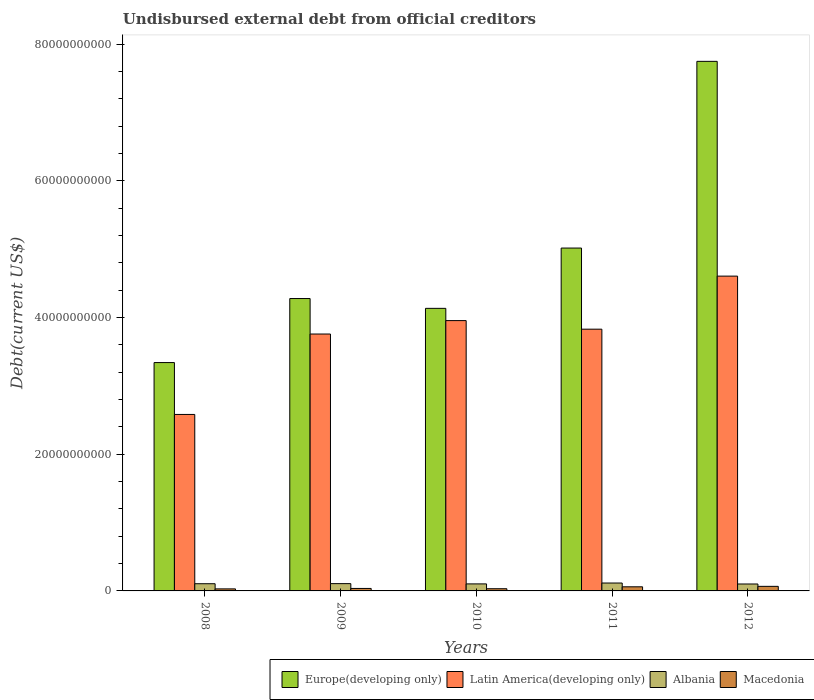How many groups of bars are there?
Make the answer very short. 5. Are the number of bars per tick equal to the number of legend labels?
Your response must be concise. Yes. Are the number of bars on each tick of the X-axis equal?
Ensure brevity in your answer.  Yes. How many bars are there on the 3rd tick from the right?
Give a very brief answer. 4. In how many cases, is the number of bars for a given year not equal to the number of legend labels?
Provide a short and direct response. 0. What is the total debt in Latin America(developing only) in 2008?
Provide a succinct answer. 2.58e+1. Across all years, what is the maximum total debt in Latin America(developing only)?
Ensure brevity in your answer.  4.61e+1. Across all years, what is the minimum total debt in Macedonia?
Offer a very short reply. 2.98e+08. In which year was the total debt in Europe(developing only) minimum?
Your answer should be compact. 2008. What is the total total debt in Europe(developing only) in the graph?
Provide a short and direct response. 2.45e+11. What is the difference between the total debt in Albania in 2008 and that in 2012?
Make the answer very short. 3.99e+07. What is the difference between the total debt in Macedonia in 2008 and the total debt in Europe(developing only) in 2012?
Provide a succinct answer. -7.72e+1. What is the average total debt in Latin America(developing only) per year?
Make the answer very short. 3.75e+1. In the year 2010, what is the difference between the total debt in Europe(developing only) and total debt in Latin America(developing only)?
Offer a very short reply. 1.79e+09. In how many years, is the total debt in Latin America(developing only) greater than 24000000000 US$?
Keep it short and to the point. 5. What is the ratio of the total debt in Latin America(developing only) in 2008 to that in 2009?
Ensure brevity in your answer.  0.69. Is the total debt in Latin America(developing only) in 2010 less than that in 2011?
Keep it short and to the point. No. What is the difference between the highest and the second highest total debt in Albania?
Offer a terse response. 8.86e+07. What is the difference between the highest and the lowest total debt in Macedonia?
Your answer should be very brief. 3.71e+08. In how many years, is the total debt in Macedonia greater than the average total debt in Macedonia taken over all years?
Provide a succinct answer. 2. Is the sum of the total debt in Macedonia in 2009 and 2012 greater than the maximum total debt in Albania across all years?
Ensure brevity in your answer.  No. What does the 4th bar from the left in 2011 represents?
Ensure brevity in your answer.  Macedonia. What does the 1st bar from the right in 2011 represents?
Provide a short and direct response. Macedonia. Is it the case that in every year, the sum of the total debt in Macedonia and total debt in Latin America(developing only) is greater than the total debt in Albania?
Make the answer very short. Yes. Are all the bars in the graph horizontal?
Ensure brevity in your answer.  No. How many years are there in the graph?
Offer a terse response. 5. Does the graph contain grids?
Keep it short and to the point. No. How many legend labels are there?
Provide a succinct answer. 4. How are the legend labels stacked?
Give a very brief answer. Horizontal. What is the title of the graph?
Provide a succinct answer. Undisbursed external debt from official creditors. Does "Nepal" appear as one of the legend labels in the graph?
Make the answer very short. No. What is the label or title of the Y-axis?
Give a very brief answer. Debt(current US$). What is the Debt(current US$) of Europe(developing only) in 2008?
Keep it short and to the point. 3.34e+1. What is the Debt(current US$) in Latin America(developing only) in 2008?
Ensure brevity in your answer.  2.58e+1. What is the Debt(current US$) in Albania in 2008?
Offer a terse response. 1.05e+09. What is the Debt(current US$) in Macedonia in 2008?
Make the answer very short. 2.98e+08. What is the Debt(current US$) of Europe(developing only) in 2009?
Your answer should be very brief. 4.28e+1. What is the Debt(current US$) of Latin America(developing only) in 2009?
Keep it short and to the point. 3.76e+1. What is the Debt(current US$) of Albania in 2009?
Your answer should be compact. 1.07e+09. What is the Debt(current US$) in Macedonia in 2009?
Keep it short and to the point. 3.63e+08. What is the Debt(current US$) in Europe(developing only) in 2010?
Give a very brief answer. 4.13e+1. What is the Debt(current US$) of Latin America(developing only) in 2010?
Provide a succinct answer. 3.95e+1. What is the Debt(current US$) of Albania in 2010?
Make the answer very short. 1.03e+09. What is the Debt(current US$) in Macedonia in 2010?
Your answer should be compact. 3.21e+08. What is the Debt(current US$) in Europe(developing only) in 2011?
Your response must be concise. 5.02e+1. What is the Debt(current US$) in Latin America(developing only) in 2011?
Provide a short and direct response. 3.83e+1. What is the Debt(current US$) of Albania in 2011?
Your answer should be very brief. 1.16e+09. What is the Debt(current US$) in Macedonia in 2011?
Offer a terse response. 6.02e+08. What is the Debt(current US$) of Europe(developing only) in 2012?
Offer a terse response. 7.75e+1. What is the Debt(current US$) of Latin America(developing only) in 2012?
Offer a very short reply. 4.61e+1. What is the Debt(current US$) in Albania in 2012?
Make the answer very short. 1.01e+09. What is the Debt(current US$) in Macedonia in 2012?
Ensure brevity in your answer.  6.68e+08. Across all years, what is the maximum Debt(current US$) in Europe(developing only)?
Make the answer very short. 7.75e+1. Across all years, what is the maximum Debt(current US$) of Latin America(developing only)?
Your response must be concise. 4.61e+1. Across all years, what is the maximum Debt(current US$) of Albania?
Make the answer very short. 1.16e+09. Across all years, what is the maximum Debt(current US$) in Macedonia?
Keep it short and to the point. 6.68e+08. Across all years, what is the minimum Debt(current US$) of Europe(developing only)?
Your answer should be compact. 3.34e+1. Across all years, what is the minimum Debt(current US$) in Latin America(developing only)?
Provide a short and direct response. 2.58e+1. Across all years, what is the minimum Debt(current US$) of Albania?
Keep it short and to the point. 1.01e+09. Across all years, what is the minimum Debt(current US$) in Macedonia?
Provide a succinct answer. 2.98e+08. What is the total Debt(current US$) in Europe(developing only) in the graph?
Ensure brevity in your answer.  2.45e+11. What is the total Debt(current US$) of Latin America(developing only) in the graph?
Your answer should be very brief. 1.87e+11. What is the total Debt(current US$) of Albania in the graph?
Give a very brief answer. 5.32e+09. What is the total Debt(current US$) of Macedonia in the graph?
Offer a terse response. 2.25e+09. What is the difference between the Debt(current US$) in Europe(developing only) in 2008 and that in 2009?
Your answer should be compact. -9.37e+09. What is the difference between the Debt(current US$) of Latin America(developing only) in 2008 and that in 2009?
Your response must be concise. -1.18e+1. What is the difference between the Debt(current US$) of Albania in 2008 and that in 2009?
Make the answer very short. -1.40e+07. What is the difference between the Debt(current US$) in Macedonia in 2008 and that in 2009?
Offer a very short reply. -6.54e+07. What is the difference between the Debt(current US$) in Europe(developing only) in 2008 and that in 2010?
Provide a succinct answer. -7.93e+09. What is the difference between the Debt(current US$) in Latin America(developing only) in 2008 and that in 2010?
Offer a very short reply. -1.37e+1. What is the difference between the Debt(current US$) in Albania in 2008 and that in 2010?
Give a very brief answer. 2.57e+07. What is the difference between the Debt(current US$) in Macedonia in 2008 and that in 2010?
Your answer should be compact. -2.33e+07. What is the difference between the Debt(current US$) of Europe(developing only) in 2008 and that in 2011?
Keep it short and to the point. -1.68e+1. What is the difference between the Debt(current US$) of Latin America(developing only) in 2008 and that in 2011?
Ensure brevity in your answer.  -1.25e+1. What is the difference between the Debt(current US$) in Albania in 2008 and that in 2011?
Provide a short and direct response. -1.03e+08. What is the difference between the Debt(current US$) in Macedonia in 2008 and that in 2011?
Give a very brief answer. -3.05e+08. What is the difference between the Debt(current US$) of Europe(developing only) in 2008 and that in 2012?
Your answer should be very brief. -4.41e+1. What is the difference between the Debt(current US$) of Latin America(developing only) in 2008 and that in 2012?
Give a very brief answer. -2.02e+1. What is the difference between the Debt(current US$) of Albania in 2008 and that in 2012?
Your response must be concise. 3.99e+07. What is the difference between the Debt(current US$) in Macedonia in 2008 and that in 2012?
Provide a short and direct response. -3.71e+08. What is the difference between the Debt(current US$) of Europe(developing only) in 2009 and that in 2010?
Ensure brevity in your answer.  1.44e+09. What is the difference between the Debt(current US$) of Latin America(developing only) in 2009 and that in 2010?
Your response must be concise. -1.96e+09. What is the difference between the Debt(current US$) in Albania in 2009 and that in 2010?
Offer a terse response. 3.97e+07. What is the difference between the Debt(current US$) in Macedonia in 2009 and that in 2010?
Ensure brevity in your answer.  4.20e+07. What is the difference between the Debt(current US$) in Europe(developing only) in 2009 and that in 2011?
Provide a succinct answer. -7.39e+09. What is the difference between the Debt(current US$) in Latin America(developing only) in 2009 and that in 2011?
Provide a succinct answer. -7.08e+08. What is the difference between the Debt(current US$) in Albania in 2009 and that in 2011?
Offer a terse response. -8.86e+07. What is the difference between the Debt(current US$) in Macedonia in 2009 and that in 2011?
Offer a very short reply. -2.39e+08. What is the difference between the Debt(current US$) of Europe(developing only) in 2009 and that in 2012?
Provide a succinct answer. -3.47e+1. What is the difference between the Debt(current US$) of Latin America(developing only) in 2009 and that in 2012?
Provide a succinct answer. -8.47e+09. What is the difference between the Debt(current US$) of Albania in 2009 and that in 2012?
Make the answer very short. 5.39e+07. What is the difference between the Debt(current US$) of Macedonia in 2009 and that in 2012?
Keep it short and to the point. -3.05e+08. What is the difference between the Debt(current US$) in Europe(developing only) in 2010 and that in 2011?
Make the answer very short. -8.82e+09. What is the difference between the Debt(current US$) in Latin America(developing only) in 2010 and that in 2011?
Offer a very short reply. 1.25e+09. What is the difference between the Debt(current US$) of Albania in 2010 and that in 2011?
Make the answer very short. -1.28e+08. What is the difference between the Debt(current US$) in Macedonia in 2010 and that in 2011?
Your answer should be very brief. -2.81e+08. What is the difference between the Debt(current US$) of Europe(developing only) in 2010 and that in 2012?
Offer a terse response. -3.61e+1. What is the difference between the Debt(current US$) of Latin America(developing only) in 2010 and that in 2012?
Your answer should be compact. -6.51e+09. What is the difference between the Debt(current US$) in Albania in 2010 and that in 2012?
Offer a very short reply. 1.42e+07. What is the difference between the Debt(current US$) of Macedonia in 2010 and that in 2012?
Provide a short and direct response. -3.47e+08. What is the difference between the Debt(current US$) in Europe(developing only) in 2011 and that in 2012?
Make the answer very short. -2.73e+1. What is the difference between the Debt(current US$) in Latin America(developing only) in 2011 and that in 2012?
Your response must be concise. -7.76e+09. What is the difference between the Debt(current US$) in Albania in 2011 and that in 2012?
Give a very brief answer. 1.43e+08. What is the difference between the Debt(current US$) in Macedonia in 2011 and that in 2012?
Your answer should be very brief. -6.60e+07. What is the difference between the Debt(current US$) in Europe(developing only) in 2008 and the Debt(current US$) in Latin America(developing only) in 2009?
Your answer should be very brief. -4.18e+09. What is the difference between the Debt(current US$) of Europe(developing only) in 2008 and the Debt(current US$) of Albania in 2009?
Make the answer very short. 3.23e+1. What is the difference between the Debt(current US$) in Europe(developing only) in 2008 and the Debt(current US$) in Macedonia in 2009?
Ensure brevity in your answer.  3.30e+1. What is the difference between the Debt(current US$) in Latin America(developing only) in 2008 and the Debt(current US$) in Albania in 2009?
Ensure brevity in your answer.  2.48e+1. What is the difference between the Debt(current US$) of Latin America(developing only) in 2008 and the Debt(current US$) of Macedonia in 2009?
Your response must be concise. 2.55e+1. What is the difference between the Debt(current US$) of Albania in 2008 and the Debt(current US$) of Macedonia in 2009?
Make the answer very short. 6.90e+08. What is the difference between the Debt(current US$) of Europe(developing only) in 2008 and the Debt(current US$) of Latin America(developing only) in 2010?
Ensure brevity in your answer.  -6.14e+09. What is the difference between the Debt(current US$) in Europe(developing only) in 2008 and the Debt(current US$) in Albania in 2010?
Give a very brief answer. 3.24e+1. What is the difference between the Debt(current US$) in Europe(developing only) in 2008 and the Debt(current US$) in Macedonia in 2010?
Provide a succinct answer. 3.31e+1. What is the difference between the Debt(current US$) in Latin America(developing only) in 2008 and the Debt(current US$) in Albania in 2010?
Ensure brevity in your answer.  2.48e+1. What is the difference between the Debt(current US$) of Latin America(developing only) in 2008 and the Debt(current US$) of Macedonia in 2010?
Keep it short and to the point. 2.55e+1. What is the difference between the Debt(current US$) in Albania in 2008 and the Debt(current US$) in Macedonia in 2010?
Provide a short and direct response. 7.32e+08. What is the difference between the Debt(current US$) of Europe(developing only) in 2008 and the Debt(current US$) of Latin America(developing only) in 2011?
Keep it short and to the point. -4.89e+09. What is the difference between the Debt(current US$) in Europe(developing only) in 2008 and the Debt(current US$) in Albania in 2011?
Provide a short and direct response. 3.23e+1. What is the difference between the Debt(current US$) of Europe(developing only) in 2008 and the Debt(current US$) of Macedonia in 2011?
Your answer should be very brief. 3.28e+1. What is the difference between the Debt(current US$) in Latin America(developing only) in 2008 and the Debt(current US$) in Albania in 2011?
Make the answer very short. 2.47e+1. What is the difference between the Debt(current US$) of Latin America(developing only) in 2008 and the Debt(current US$) of Macedonia in 2011?
Provide a short and direct response. 2.52e+1. What is the difference between the Debt(current US$) in Albania in 2008 and the Debt(current US$) in Macedonia in 2011?
Your response must be concise. 4.51e+08. What is the difference between the Debt(current US$) of Europe(developing only) in 2008 and the Debt(current US$) of Latin America(developing only) in 2012?
Your response must be concise. -1.26e+1. What is the difference between the Debt(current US$) of Europe(developing only) in 2008 and the Debt(current US$) of Albania in 2012?
Offer a terse response. 3.24e+1. What is the difference between the Debt(current US$) of Europe(developing only) in 2008 and the Debt(current US$) of Macedonia in 2012?
Make the answer very short. 3.27e+1. What is the difference between the Debt(current US$) in Latin America(developing only) in 2008 and the Debt(current US$) in Albania in 2012?
Ensure brevity in your answer.  2.48e+1. What is the difference between the Debt(current US$) in Latin America(developing only) in 2008 and the Debt(current US$) in Macedonia in 2012?
Offer a very short reply. 2.52e+1. What is the difference between the Debt(current US$) in Albania in 2008 and the Debt(current US$) in Macedonia in 2012?
Your answer should be very brief. 3.85e+08. What is the difference between the Debt(current US$) of Europe(developing only) in 2009 and the Debt(current US$) of Latin America(developing only) in 2010?
Your answer should be compact. 3.23e+09. What is the difference between the Debt(current US$) of Europe(developing only) in 2009 and the Debt(current US$) of Albania in 2010?
Keep it short and to the point. 4.18e+1. What is the difference between the Debt(current US$) in Europe(developing only) in 2009 and the Debt(current US$) in Macedonia in 2010?
Provide a succinct answer. 4.25e+1. What is the difference between the Debt(current US$) in Latin America(developing only) in 2009 and the Debt(current US$) in Albania in 2010?
Your response must be concise. 3.66e+1. What is the difference between the Debt(current US$) of Latin America(developing only) in 2009 and the Debt(current US$) of Macedonia in 2010?
Your response must be concise. 3.73e+1. What is the difference between the Debt(current US$) in Albania in 2009 and the Debt(current US$) in Macedonia in 2010?
Provide a succinct answer. 7.46e+08. What is the difference between the Debt(current US$) of Europe(developing only) in 2009 and the Debt(current US$) of Latin America(developing only) in 2011?
Your response must be concise. 4.48e+09. What is the difference between the Debt(current US$) in Europe(developing only) in 2009 and the Debt(current US$) in Albania in 2011?
Offer a terse response. 4.16e+1. What is the difference between the Debt(current US$) in Europe(developing only) in 2009 and the Debt(current US$) in Macedonia in 2011?
Offer a terse response. 4.22e+1. What is the difference between the Debt(current US$) in Latin America(developing only) in 2009 and the Debt(current US$) in Albania in 2011?
Offer a terse response. 3.64e+1. What is the difference between the Debt(current US$) of Latin America(developing only) in 2009 and the Debt(current US$) of Macedonia in 2011?
Keep it short and to the point. 3.70e+1. What is the difference between the Debt(current US$) in Albania in 2009 and the Debt(current US$) in Macedonia in 2011?
Provide a short and direct response. 4.65e+08. What is the difference between the Debt(current US$) in Europe(developing only) in 2009 and the Debt(current US$) in Latin America(developing only) in 2012?
Make the answer very short. -3.28e+09. What is the difference between the Debt(current US$) in Europe(developing only) in 2009 and the Debt(current US$) in Albania in 2012?
Your answer should be compact. 4.18e+1. What is the difference between the Debt(current US$) of Europe(developing only) in 2009 and the Debt(current US$) of Macedonia in 2012?
Your answer should be compact. 4.21e+1. What is the difference between the Debt(current US$) of Latin America(developing only) in 2009 and the Debt(current US$) of Albania in 2012?
Provide a short and direct response. 3.66e+1. What is the difference between the Debt(current US$) of Latin America(developing only) in 2009 and the Debt(current US$) of Macedonia in 2012?
Offer a terse response. 3.69e+1. What is the difference between the Debt(current US$) in Albania in 2009 and the Debt(current US$) in Macedonia in 2012?
Keep it short and to the point. 3.99e+08. What is the difference between the Debt(current US$) of Europe(developing only) in 2010 and the Debt(current US$) of Latin America(developing only) in 2011?
Make the answer very short. 3.05e+09. What is the difference between the Debt(current US$) of Europe(developing only) in 2010 and the Debt(current US$) of Albania in 2011?
Your response must be concise. 4.02e+1. What is the difference between the Debt(current US$) in Europe(developing only) in 2010 and the Debt(current US$) in Macedonia in 2011?
Your response must be concise. 4.07e+1. What is the difference between the Debt(current US$) in Latin America(developing only) in 2010 and the Debt(current US$) in Albania in 2011?
Give a very brief answer. 3.84e+1. What is the difference between the Debt(current US$) in Latin America(developing only) in 2010 and the Debt(current US$) in Macedonia in 2011?
Provide a short and direct response. 3.89e+1. What is the difference between the Debt(current US$) of Albania in 2010 and the Debt(current US$) of Macedonia in 2011?
Your answer should be compact. 4.25e+08. What is the difference between the Debt(current US$) of Europe(developing only) in 2010 and the Debt(current US$) of Latin America(developing only) in 2012?
Make the answer very short. -4.72e+09. What is the difference between the Debt(current US$) of Europe(developing only) in 2010 and the Debt(current US$) of Albania in 2012?
Offer a terse response. 4.03e+1. What is the difference between the Debt(current US$) of Europe(developing only) in 2010 and the Debt(current US$) of Macedonia in 2012?
Provide a short and direct response. 4.07e+1. What is the difference between the Debt(current US$) in Latin America(developing only) in 2010 and the Debt(current US$) in Albania in 2012?
Your answer should be very brief. 3.85e+1. What is the difference between the Debt(current US$) of Latin America(developing only) in 2010 and the Debt(current US$) of Macedonia in 2012?
Provide a succinct answer. 3.89e+1. What is the difference between the Debt(current US$) of Albania in 2010 and the Debt(current US$) of Macedonia in 2012?
Provide a succinct answer. 3.59e+08. What is the difference between the Debt(current US$) in Europe(developing only) in 2011 and the Debt(current US$) in Latin America(developing only) in 2012?
Provide a short and direct response. 4.11e+09. What is the difference between the Debt(current US$) of Europe(developing only) in 2011 and the Debt(current US$) of Albania in 2012?
Your answer should be compact. 4.92e+1. What is the difference between the Debt(current US$) of Europe(developing only) in 2011 and the Debt(current US$) of Macedonia in 2012?
Your answer should be very brief. 4.95e+1. What is the difference between the Debt(current US$) of Latin America(developing only) in 2011 and the Debt(current US$) of Albania in 2012?
Your answer should be compact. 3.73e+1. What is the difference between the Debt(current US$) of Latin America(developing only) in 2011 and the Debt(current US$) of Macedonia in 2012?
Give a very brief answer. 3.76e+1. What is the difference between the Debt(current US$) of Albania in 2011 and the Debt(current US$) of Macedonia in 2012?
Give a very brief answer. 4.87e+08. What is the average Debt(current US$) of Europe(developing only) per year?
Keep it short and to the point. 4.90e+1. What is the average Debt(current US$) in Latin America(developing only) per year?
Make the answer very short. 3.75e+1. What is the average Debt(current US$) of Albania per year?
Offer a terse response. 1.06e+09. What is the average Debt(current US$) in Macedonia per year?
Your answer should be compact. 4.50e+08. In the year 2008, what is the difference between the Debt(current US$) of Europe(developing only) and Debt(current US$) of Latin America(developing only)?
Provide a succinct answer. 7.59e+09. In the year 2008, what is the difference between the Debt(current US$) in Europe(developing only) and Debt(current US$) in Albania?
Your answer should be compact. 3.24e+1. In the year 2008, what is the difference between the Debt(current US$) in Europe(developing only) and Debt(current US$) in Macedonia?
Give a very brief answer. 3.31e+1. In the year 2008, what is the difference between the Debt(current US$) of Latin America(developing only) and Debt(current US$) of Albania?
Give a very brief answer. 2.48e+1. In the year 2008, what is the difference between the Debt(current US$) of Latin America(developing only) and Debt(current US$) of Macedonia?
Your answer should be compact. 2.55e+1. In the year 2008, what is the difference between the Debt(current US$) of Albania and Debt(current US$) of Macedonia?
Your answer should be compact. 7.55e+08. In the year 2009, what is the difference between the Debt(current US$) in Europe(developing only) and Debt(current US$) in Latin America(developing only)?
Your answer should be very brief. 5.19e+09. In the year 2009, what is the difference between the Debt(current US$) in Europe(developing only) and Debt(current US$) in Albania?
Provide a short and direct response. 4.17e+1. In the year 2009, what is the difference between the Debt(current US$) of Europe(developing only) and Debt(current US$) of Macedonia?
Make the answer very short. 4.24e+1. In the year 2009, what is the difference between the Debt(current US$) of Latin America(developing only) and Debt(current US$) of Albania?
Make the answer very short. 3.65e+1. In the year 2009, what is the difference between the Debt(current US$) of Latin America(developing only) and Debt(current US$) of Macedonia?
Give a very brief answer. 3.72e+1. In the year 2009, what is the difference between the Debt(current US$) in Albania and Debt(current US$) in Macedonia?
Provide a succinct answer. 7.04e+08. In the year 2010, what is the difference between the Debt(current US$) of Europe(developing only) and Debt(current US$) of Latin America(developing only)?
Your answer should be very brief. 1.79e+09. In the year 2010, what is the difference between the Debt(current US$) in Europe(developing only) and Debt(current US$) in Albania?
Your answer should be very brief. 4.03e+1. In the year 2010, what is the difference between the Debt(current US$) of Europe(developing only) and Debt(current US$) of Macedonia?
Offer a terse response. 4.10e+1. In the year 2010, what is the difference between the Debt(current US$) in Latin America(developing only) and Debt(current US$) in Albania?
Your answer should be compact. 3.85e+1. In the year 2010, what is the difference between the Debt(current US$) of Latin America(developing only) and Debt(current US$) of Macedonia?
Offer a very short reply. 3.92e+1. In the year 2010, what is the difference between the Debt(current US$) of Albania and Debt(current US$) of Macedonia?
Ensure brevity in your answer.  7.06e+08. In the year 2011, what is the difference between the Debt(current US$) of Europe(developing only) and Debt(current US$) of Latin America(developing only)?
Provide a succinct answer. 1.19e+1. In the year 2011, what is the difference between the Debt(current US$) in Europe(developing only) and Debt(current US$) in Albania?
Provide a succinct answer. 4.90e+1. In the year 2011, what is the difference between the Debt(current US$) of Europe(developing only) and Debt(current US$) of Macedonia?
Ensure brevity in your answer.  4.96e+1. In the year 2011, what is the difference between the Debt(current US$) of Latin America(developing only) and Debt(current US$) of Albania?
Your response must be concise. 3.71e+1. In the year 2011, what is the difference between the Debt(current US$) in Latin America(developing only) and Debt(current US$) in Macedonia?
Provide a short and direct response. 3.77e+1. In the year 2011, what is the difference between the Debt(current US$) in Albania and Debt(current US$) in Macedonia?
Your answer should be compact. 5.53e+08. In the year 2012, what is the difference between the Debt(current US$) in Europe(developing only) and Debt(current US$) in Latin America(developing only)?
Make the answer very short. 3.14e+1. In the year 2012, what is the difference between the Debt(current US$) of Europe(developing only) and Debt(current US$) of Albania?
Your answer should be very brief. 7.65e+1. In the year 2012, what is the difference between the Debt(current US$) in Europe(developing only) and Debt(current US$) in Macedonia?
Make the answer very short. 7.68e+1. In the year 2012, what is the difference between the Debt(current US$) in Latin America(developing only) and Debt(current US$) in Albania?
Your answer should be very brief. 4.50e+1. In the year 2012, what is the difference between the Debt(current US$) of Latin America(developing only) and Debt(current US$) of Macedonia?
Your response must be concise. 4.54e+1. In the year 2012, what is the difference between the Debt(current US$) of Albania and Debt(current US$) of Macedonia?
Make the answer very short. 3.45e+08. What is the ratio of the Debt(current US$) in Europe(developing only) in 2008 to that in 2009?
Your answer should be very brief. 0.78. What is the ratio of the Debt(current US$) of Latin America(developing only) in 2008 to that in 2009?
Give a very brief answer. 0.69. What is the ratio of the Debt(current US$) of Albania in 2008 to that in 2009?
Your answer should be compact. 0.99. What is the ratio of the Debt(current US$) in Macedonia in 2008 to that in 2009?
Your answer should be very brief. 0.82. What is the ratio of the Debt(current US$) of Europe(developing only) in 2008 to that in 2010?
Your answer should be very brief. 0.81. What is the ratio of the Debt(current US$) of Latin America(developing only) in 2008 to that in 2010?
Keep it short and to the point. 0.65. What is the ratio of the Debt(current US$) in Macedonia in 2008 to that in 2010?
Offer a terse response. 0.93. What is the ratio of the Debt(current US$) of Europe(developing only) in 2008 to that in 2011?
Ensure brevity in your answer.  0.67. What is the ratio of the Debt(current US$) in Latin America(developing only) in 2008 to that in 2011?
Give a very brief answer. 0.67. What is the ratio of the Debt(current US$) in Albania in 2008 to that in 2011?
Ensure brevity in your answer.  0.91. What is the ratio of the Debt(current US$) in Macedonia in 2008 to that in 2011?
Provide a short and direct response. 0.49. What is the ratio of the Debt(current US$) of Europe(developing only) in 2008 to that in 2012?
Your answer should be very brief. 0.43. What is the ratio of the Debt(current US$) in Latin America(developing only) in 2008 to that in 2012?
Keep it short and to the point. 0.56. What is the ratio of the Debt(current US$) of Albania in 2008 to that in 2012?
Offer a terse response. 1.04. What is the ratio of the Debt(current US$) of Macedonia in 2008 to that in 2012?
Your response must be concise. 0.45. What is the ratio of the Debt(current US$) of Europe(developing only) in 2009 to that in 2010?
Make the answer very short. 1.03. What is the ratio of the Debt(current US$) in Latin America(developing only) in 2009 to that in 2010?
Provide a short and direct response. 0.95. What is the ratio of the Debt(current US$) in Albania in 2009 to that in 2010?
Provide a succinct answer. 1.04. What is the ratio of the Debt(current US$) of Macedonia in 2009 to that in 2010?
Offer a terse response. 1.13. What is the ratio of the Debt(current US$) of Europe(developing only) in 2009 to that in 2011?
Make the answer very short. 0.85. What is the ratio of the Debt(current US$) of Latin America(developing only) in 2009 to that in 2011?
Your response must be concise. 0.98. What is the ratio of the Debt(current US$) of Albania in 2009 to that in 2011?
Your response must be concise. 0.92. What is the ratio of the Debt(current US$) in Macedonia in 2009 to that in 2011?
Your answer should be compact. 0.6. What is the ratio of the Debt(current US$) in Europe(developing only) in 2009 to that in 2012?
Your response must be concise. 0.55. What is the ratio of the Debt(current US$) of Latin America(developing only) in 2009 to that in 2012?
Your answer should be compact. 0.82. What is the ratio of the Debt(current US$) of Albania in 2009 to that in 2012?
Provide a succinct answer. 1.05. What is the ratio of the Debt(current US$) of Macedonia in 2009 to that in 2012?
Offer a very short reply. 0.54. What is the ratio of the Debt(current US$) in Europe(developing only) in 2010 to that in 2011?
Keep it short and to the point. 0.82. What is the ratio of the Debt(current US$) of Latin America(developing only) in 2010 to that in 2011?
Offer a very short reply. 1.03. What is the ratio of the Debt(current US$) in Albania in 2010 to that in 2011?
Ensure brevity in your answer.  0.89. What is the ratio of the Debt(current US$) in Macedonia in 2010 to that in 2011?
Offer a very short reply. 0.53. What is the ratio of the Debt(current US$) in Europe(developing only) in 2010 to that in 2012?
Provide a short and direct response. 0.53. What is the ratio of the Debt(current US$) of Latin America(developing only) in 2010 to that in 2012?
Your answer should be compact. 0.86. What is the ratio of the Debt(current US$) of Macedonia in 2010 to that in 2012?
Offer a very short reply. 0.48. What is the ratio of the Debt(current US$) of Europe(developing only) in 2011 to that in 2012?
Offer a very short reply. 0.65. What is the ratio of the Debt(current US$) of Latin America(developing only) in 2011 to that in 2012?
Keep it short and to the point. 0.83. What is the ratio of the Debt(current US$) in Albania in 2011 to that in 2012?
Offer a terse response. 1.14. What is the ratio of the Debt(current US$) of Macedonia in 2011 to that in 2012?
Make the answer very short. 0.9. What is the difference between the highest and the second highest Debt(current US$) in Europe(developing only)?
Your response must be concise. 2.73e+1. What is the difference between the highest and the second highest Debt(current US$) of Latin America(developing only)?
Your answer should be very brief. 6.51e+09. What is the difference between the highest and the second highest Debt(current US$) of Albania?
Keep it short and to the point. 8.86e+07. What is the difference between the highest and the second highest Debt(current US$) of Macedonia?
Your answer should be compact. 6.60e+07. What is the difference between the highest and the lowest Debt(current US$) in Europe(developing only)?
Provide a short and direct response. 4.41e+1. What is the difference between the highest and the lowest Debt(current US$) in Latin America(developing only)?
Keep it short and to the point. 2.02e+1. What is the difference between the highest and the lowest Debt(current US$) in Albania?
Offer a terse response. 1.43e+08. What is the difference between the highest and the lowest Debt(current US$) in Macedonia?
Your response must be concise. 3.71e+08. 